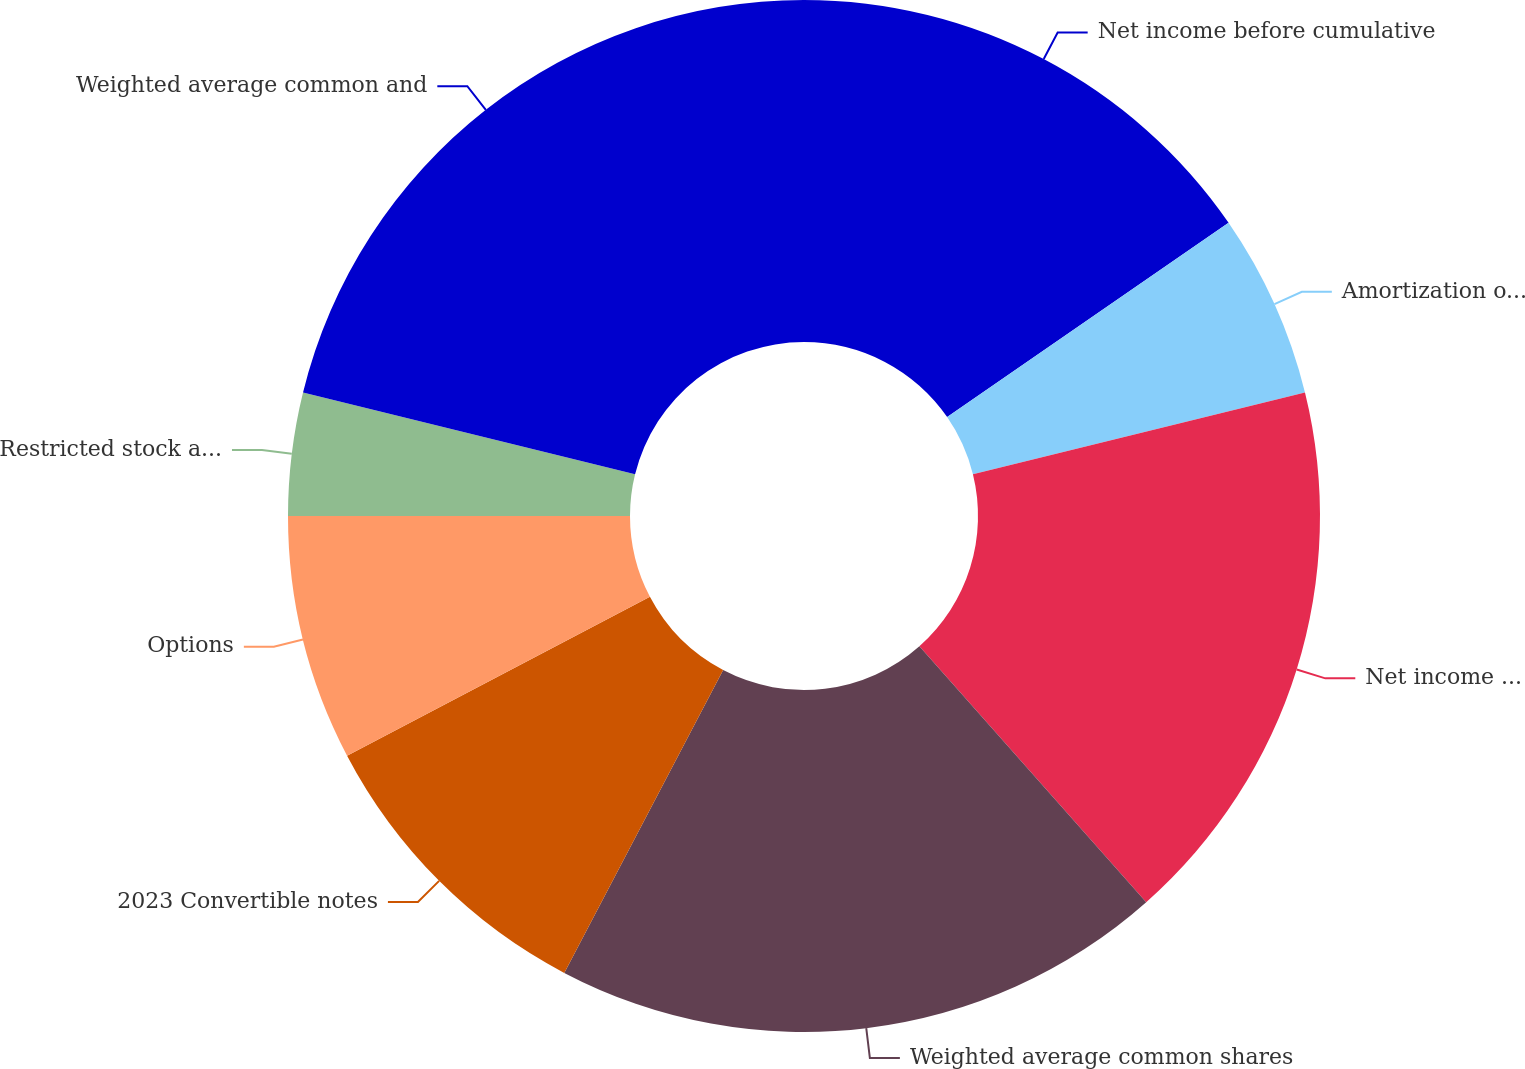Convert chart. <chart><loc_0><loc_0><loc_500><loc_500><pie_chart><fcel>Net income before cumulative<fcel>Amortization of 2023<fcel>Net income after cumulative<fcel>Weighted average common shares<fcel>2023 Convertible notes<fcel>Options<fcel>Restricted stock and ESPP<fcel>Weighted average common and<nl><fcel>15.38%<fcel>5.77%<fcel>17.31%<fcel>19.23%<fcel>9.62%<fcel>7.69%<fcel>3.85%<fcel>21.15%<nl></chart> 